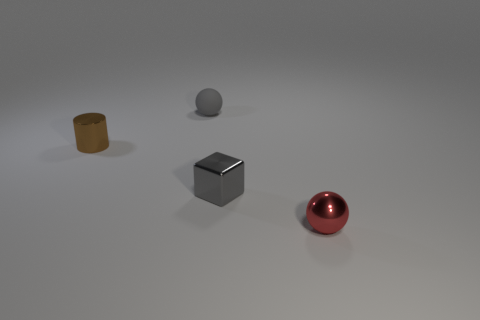There is a small metal thing that is the same color as the rubber sphere; what is its shape?
Keep it short and to the point. Cube. Are there the same number of shiny things that are behind the tiny gray shiny cube and small red things that are to the left of the small matte thing?
Your response must be concise. No. How many objects are either yellow metallic objects or tiny gray things behind the small brown object?
Give a very brief answer. 1. What is the shape of the small metallic object that is both on the left side of the red thing and to the right of the brown cylinder?
Offer a very short reply. Cube. The thing that is to the left of the tiny object that is behind the brown thing is made of what material?
Make the answer very short. Metal. Does the sphere that is behind the brown object have the same material as the small red sphere?
Provide a short and direct response. No. There is a sphere that is behind the gray cube; how big is it?
Ensure brevity in your answer.  Small. There is a small metallic thing left of the small gray matte ball; are there any metal cylinders behind it?
Make the answer very short. No. There is a ball to the left of the tiny red metallic sphere; does it have the same color as the sphere that is in front of the tiny brown metallic cylinder?
Keep it short and to the point. No. The tiny metallic cylinder has what color?
Give a very brief answer. Brown. 